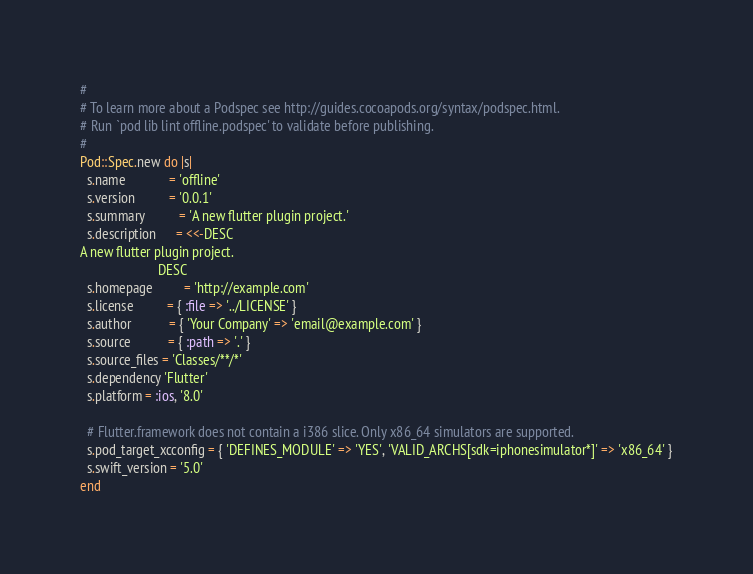<code> <loc_0><loc_0><loc_500><loc_500><_Ruby_>#
# To learn more about a Podspec see http://guides.cocoapods.org/syntax/podspec.html.
# Run `pod lib lint offline.podspec' to validate before publishing.
#
Pod::Spec.new do |s|
  s.name             = 'offline'
  s.version          = '0.0.1'
  s.summary          = 'A new flutter plugin project.'
  s.description      = <<-DESC
A new flutter plugin project.
                       DESC
  s.homepage         = 'http://example.com'
  s.license          = { :file => '../LICENSE' }
  s.author           = { 'Your Company' => 'email@example.com' }
  s.source           = { :path => '.' }
  s.source_files = 'Classes/**/*'
  s.dependency 'Flutter'
  s.platform = :ios, '8.0'

  # Flutter.framework does not contain a i386 slice. Only x86_64 simulators are supported.
  s.pod_target_xcconfig = { 'DEFINES_MODULE' => 'YES', 'VALID_ARCHS[sdk=iphonesimulator*]' => 'x86_64' }
  s.swift_version = '5.0'
end
</code> 